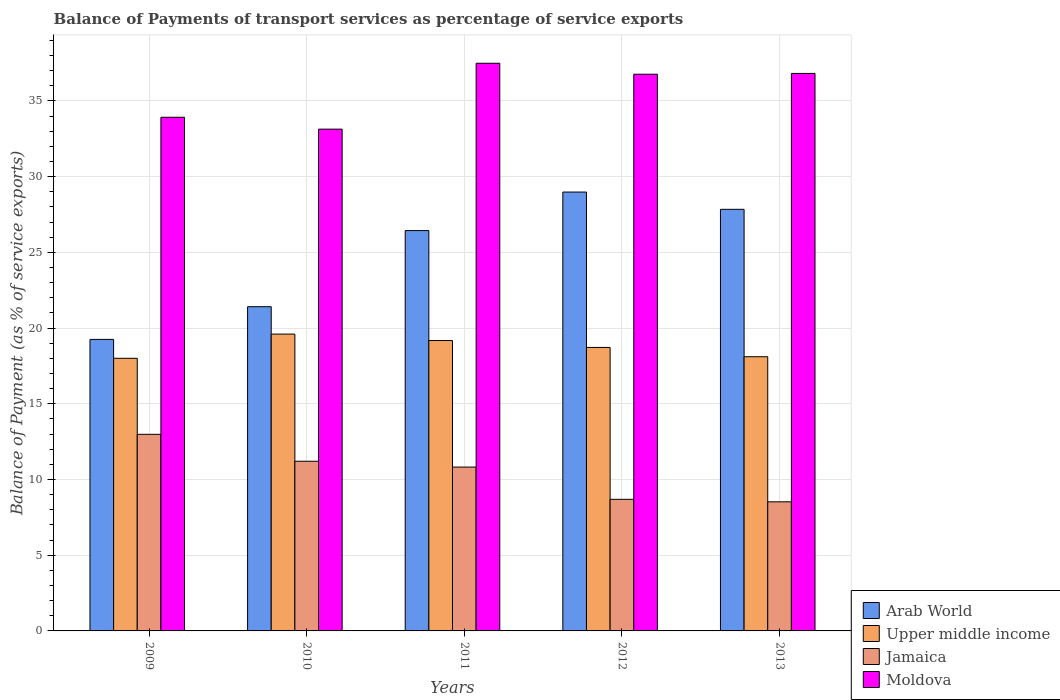How many different coloured bars are there?
Your answer should be very brief. 4. Are the number of bars on each tick of the X-axis equal?
Ensure brevity in your answer.  Yes. What is the label of the 1st group of bars from the left?
Your answer should be very brief. 2009. In how many cases, is the number of bars for a given year not equal to the number of legend labels?
Provide a succinct answer. 0. What is the balance of payments of transport services in Arab World in 2011?
Keep it short and to the point. 26.44. Across all years, what is the maximum balance of payments of transport services in Moldova?
Your response must be concise. 37.49. Across all years, what is the minimum balance of payments of transport services in Arab World?
Give a very brief answer. 19.25. In which year was the balance of payments of transport services in Moldova minimum?
Make the answer very short. 2010. What is the total balance of payments of transport services in Jamaica in the graph?
Make the answer very short. 52.23. What is the difference between the balance of payments of transport services in Jamaica in 2009 and that in 2013?
Give a very brief answer. 4.46. What is the difference between the balance of payments of transport services in Arab World in 2010 and the balance of payments of transport services in Upper middle income in 2009?
Your response must be concise. 3.41. What is the average balance of payments of transport services in Arab World per year?
Make the answer very short. 24.79. In the year 2011, what is the difference between the balance of payments of transport services in Upper middle income and balance of payments of transport services in Arab World?
Your answer should be very brief. -7.26. In how many years, is the balance of payments of transport services in Jamaica greater than 36 %?
Give a very brief answer. 0. What is the ratio of the balance of payments of transport services in Upper middle income in 2009 to that in 2010?
Offer a terse response. 0.92. Is the balance of payments of transport services in Jamaica in 2009 less than that in 2010?
Ensure brevity in your answer.  No. What is the difference between the highest and the second highest balance of payments of transport services in Upper middle income?
Offer a very short reply. 0.43. What is the difference between the highest and the lowest balance of payments of transport services in Moldova?
Ensure brevity in your answer.  4.35. In how many years, is the balance of payments of transport services in Jamaica greater than the average balance of payments of transport services in Jamaica taken over all years?
Your response must be concise. 3. What does the 4th bar from the left in 2012 represents?
Give a very brief answer. Moldova. What does the 1st bar from the right in 2011 represents?
Keep it short and to the point. Moldova. How many bars are there?
Your answer should be very brief. 20. What is the difference between two consecutive major ticks on the Y-axis?
Give a very brief answer. 5. Are the values on the major ticks of Y-axis written in scientific E-notation?
Provide a succinct answer. No. Does the graph contain any zero values?
Keep it short and to the point. No. Where does the legend appear in the graph?
Your response must be concise. Bottom right. How many legend labels are there?
Offer a terse response. 4. What is the title of the graph?
Your answer should be compact. Balance of Payments of transport services as percentage of service exports. What is the label or title of the Y-axis?
Offer a terse response. Balance of Payment (as % of service exports). What is the Balance of Payment (as % of service exports) in Arab World in 2009?
Ensure brevity in your answer.  19.25. What is the Balance of Payment (as % of service exports) in Upper middle income in 2009?
Provide a short and direct response. 18.01. What is the Balance of Payment (as % of service exports) in Jamaica in 2009?
Provide a succinct answer. 12.98. What is the Balance of Payment (as % of service exports) in Moldova in 2009?
Give a very brief answer. 33.93. What is the Balance of Payment (as % of service exports) of Arab World in 2010?
Ensure brevity in your answer.  21.41. What is the Balance of Payment (as % of service exports) of Upper middle income in 2010?
Give a very brief answer. 19.6. What is the Balance of Payment (as % of service exports) in Jamaica in 2010?
Your answer should be very brief. 11.21. What is the Balance of Payment (as % of service exports) of Moldova in 2010?
Ensure brevity in your answer.  33.14. What is the Balance of Payment (as % of service exports) in Arab World in 2011?
Offer a terse response. 26.44. What is the Balance of Payment (as % of service exports) in Upper middle income in 2011?
Your response must be concise. 19.18. What is the Balance of Payment (as % of service exports) in Jamaica in 2011?
Offer a very short reply. 10.82. What is the Balance of Payment (as % of service exports) of Moldova in 2011?
Provide a short and direct response. 37.49. What is the Balance of Payment (as % of service exports) in Arab World in 2012?
Your response must be concise. 28.99. What is the Balance of Payment (as % of service exports) in Upper middle income in 2012?
Offer a very short reply. 18.72. What is the Balance of Payment (as % of service exports) in Jamaica in 2012?
Offer a terse response. 8.69. What is the Balance of Payment (as % of service exports) in Moldova in 2012?
Keep it short and to the point. 36.77. What is the Balance of Payment (as % of service exports) of Arab World in 2013?
Keep it short and to the point. 27.85. What is the Balance of Payment (as % of service exports) of Upper middle income in 2013?
Ensure brevity in your answer.  18.11. What is the Balance of Payment (as % of service exports) of Jamaica in 2013?
Offer a terse response. 8.53. What is the Balance of Payment (as % of service exports) in Moldova in 2013?
Provide a succinct answer. 36.82. Across all years, what is the maximum Balance of Payment (as % of service exports) of Arab World?
Keep it short and to the point. 28.99. Across all years, what is the maximum Balance of Payment (as % of service exports) of Upper middle income?
Give a very brief answer. 19.6. Across all years, what is the maximum Balance of Payment (as % of service exports) in Jamaica?
Offer a very short reply. 12.98. Across all years, what is the maximum Balance of Payment (as % of service exports) of Moldova?
Your response must be concise. 37.49. Across all years, what is the minimum Balance of Payment (as % of service exports) of Arab World?
Offer a very short reply. 19.25. Across all years, what is the minimum Balance of Payment (as % of service exports) in Upper middle income?
Ensure brevity in your answer.  18.01. Across all years, what is the minimum Balance of Payment (as % of service exports) of Jamaica?
Give a very brief answer. 8.53. Across all years, what is the minimum Balance of Payment (as % of service exports) in Moldova?
Your answer should be compact. 33.14. What is the total Balance of Payment (as % of service exports) of Arab World in the graph?
Provide a short and direct response. 123.94. What is the total Balance of Payment (as % of service exports) in Upper middle income in the graph?
Make the answer very short. 93.62. What is the total Balance of Payment (as % of service exports) of Jamaica in the graph?
Offer a terse response. 52.23. What is the total Balance of Payment (as % of service exports) of Moldova in the graph?
Offer a very short reply. 178.15. What is the difference between the Balance of Payment (as % of service exports) in Arab World in 2009 and that in 2010?
Give a very brief answer. -2.16. What is the difference between the Balance of Payment (as % of service exports) of Upper middle income in 2009 and that in 2010?
Offer a terse response. -1.6. What is the difference between the Balance of Payment (as % of service exports) of Jamaica in 2009 and that in 2010?
Provide a short and direct response. 1.78. What is the difference between the Balance of Payment (as % of service exports) in Moldova in 2009 and that in 2010?
Provide a succinct answer. 0.78. What is the difference between the Balance of Payment (as % of service exports) of Arab World in 2009 and that in 2011?
Keep it short and to the point. -7.19. What is the difference between the Balance of Payment (as % of service exports) of Upper middle income in 2009 and that in 2011?
Offer a terse response. -1.17. What is the difference between the Balance of Payment (as % of service exports) in Jamaica in 2009 and that in 2011?
Give a very brief answer. 2.16. What is the difference between the Balance of Payment (as % of service exports) of Moldova in 2009 and that in 2011?
Provide a short and direct response. -3.57. What is the difference between the Balance of Payment (as % of service exports) of Arab World in 2009 and that in 2012?
Give a very brief answer. -9.73. What is the difference between the Balance of Payment (as % of service exports) of Upper middle income in 2009 and that in 2012?
Ensure brevity in your answer.  -0.72. What is the difference between the Balance of Payment (as % of service exports) in Jamaica in 2009 and that in 2012?
Make the answer very short. 4.29. What is the difference between the Balance of Payment (as % of service exports) in Moldova in 2009 and that in 2012?
Your answer should be very brief. -2.84. What is the difference between the Balance of Payment (as % of service exports) in Arab World in 2009 and that in 2013?
Offer a terse response. -8.59. What is the difference between the Balance of Payment (as % of service exports) in Upper middle income in 2009 and that in 2013?
Your answer should be compact. -0.1. What is the difference between the Balance of Payment (as % of service exports) in Jamaica in 2009 and that in 2013?
Provide a short and direct response. 4.46. What is the difference between the Balance of Payment (as % of service exports) of Moldova in 2009 and that in 2013?
Ensure brevity in your answer.  -2.9. What is the difference between the Balance of Payment (as % of service exports) of Arab World in 2010 and that in 2011?
Keep it short and to the point. -5.03. What is the difference between the Balance of Payment (as % of service exports) in Upper middle income in 2010 and that in 2011?
Provide a succinct answer. 0.43. What is the difference between the Balance of Payment (as % of service exports) in Jamaica in 2010 and that in 2011?
Provide a succinct answer. 0.39. What is the difference between the Balance of Payment (as % of service exports) of Moldova in 2010 and that in 2011?
Keep it short and to the point. -4.35. What is the difference between the Balance of Payment (as % of service exports) of Arab World in 2010 and that in 2012?
Ensure brevity in your answer.  -7.57. What is the difference between the Balance of Payment (as % of service exports) of Upper middle income in 2010 and that in 2012?
Keep it short and to the point. 0.88. What is the difference between the Balance of Payment (as % of service exports) of Jamaica in 2010 and that in 2012?
Offer a terse response. 2.52. What is the difference between the Balance of Payment (as % of service exports) of Moldova in 2010 and that in 2012?
Make the answer very short. -3.63. What is the difference between the Balance of Payment (as % of service exports) in Arab World in 2010 and that in 2013?
Offer a very short reply. -6.43. What is the difference between the Balance of Payment (as % of service exports) in Upper middle income in 2010 and that in 2013?
Your response must be concise. 1.49. What is the difference between the Balance of Payment (as % of service exports) in Jamaica in 2010 and that in 2013?
Provide a succinct answer. 2.68. What is the difference between the Balance of Payment (as % of service exports) of Moldova in 2010 and that in 2013?
Your answer should be very brief. -3.68. What is the difference between the Balance of Payment (as % of service exports) in Arab World in 2011 and that in 2012?
Give a very brief answer. -2.54. What is the difference between the Balance of Payment (as % of service exports) in Upper middle income in 2011 and that in 2012?
Give a very brief answer. 0.45. What is the difference between the Balance of Payment (as % of service exports) in Jamaica in 2011 and that in 2012?
Your answer should be compact. 2.13. What is the difference between the Balance of Payment (as % of service exports) in Moldova in 2011 and that in 2012?
Ensure brevity in your answer.  0.72. What is the difference between the Balance of Payment (as % of service exports) of Arab World in 2011 and that in 2013?
Keep it short and to the point. -1.4. What is the difference between the Balance of Payment (as % of service exports) of Upper middle income in 2011 and that in 2013?
Provide a short and direct response. 1.07. What is the difference between the Balance of Payment (as % of service exports) of Jamaica in 2011 and that in 2013?
Your response must be concise. 2.29. What is the difference between the Balance of Payment (as % of service exports) of Moldova in 2011 and that in 2013?
Your answer should be compact. 0.67. What is the difference between the Balance of Payment (as % of service exports) in Arab World in 2012 and that in 2013?
Keep it short and to the point. 1.14. What is the difference between the Balance of Payment (as % of service exports) of Upper middle income in 2012 and that in 2013?
Keep it short and to the point. 0.61. What is the difference between the Balance of Payment (as % of service exports) in Jamaica in 2012 and that in 2013?
Provide a succinct answer. 0.17. What is the difference between the Balance of Payment (as % of service exports) in Moldova in 2012 and that in 2013?
Ensure brevity in your answer.  -0.05. What is the difference between the Balance of Payment (as % of service exports) in Arab World in 2009 and the Balance of Payment (as % of service exports) in Upper middle income in 2010?
Offer a terse response. -0.35. What is the difference between the Balance of Payment (as % of service exports) in Arab World in 2009 and the Balance of Payment (as % of service exports) in Jamaica in 2010?
Offer a terse response. 8.05. What is the difference between the Balance of Payment (as % of service exports) in Arab World in 2009 and the Balance of Payment (as % of service exports) in Moldova in 2010?
Keep it short and to the point. -13.89. What is the difference between the Balance of Payment (as % of service exports) in Upper middle income in 2009 and the Balance of Payment (as % of service exports) in Jamaica in 2010?
Offer a terse response. 6.8. What is the difference between the Balance of Payment (as % of service exports) in Upper middle income in 2009 and the Balance of Payment (as % of service exports) in Moldova in 2010?
Make the answer very short. -15.13. What is the difference between the Balance of Payment (as % of service exports) of Jamaica in 2009 and the Balance of Payment (as % of service exports) of Moldova in 2010?
Keep it short and to the point. -20.16. What is the difference between the Balance of Payment (as % of service exports) of Arab World in 2009 and the Balance of Payment (as % of service exports) of Upper middle income in 2011?
Make the answer very short. 0.08. What is the difference between the Balance of Payment (as % of service exports) in Arab World in 2009 and the Balance of Payment (as % of service exports) in Jamaica in 2011?
Make the answer very short. 8.43. What is the difference between the Balance of Payment (as % of service exports) of Arab World in 2009 and the Balance of Payment (as % of service exports) of Moldova in 2011?
Ensure brevity in your answer.  -18.24. What is the difference between the Balance of Payment (as % of service exports) of Upper middle income in 2009 and the Balance of Payment (as % of service exports) of Jamaica in 2011?
Keep it short and to the point. 7.18. What is the difference between the Balance of Payment (as % of service exports) in Upper middle income in 2009 and the Balance of Payment (as % of service exports) in Moldova in 2011?
Your response must be concise. -19.49. What is the difference between the Balance of Payment (as % of service exports) in Jamaica in 2009 and the Balance of Payment (as % of service exports) in Moldova in 2011?
Give a very brief answer. -24.51. What is the difference between the Balance of Payment (as % of service exports) of Arab World in 2009 and the Balance of Payment (as % of service exports) of Upper middle income in 2012?
Offer a terse response. 0.53. What is the difference between the Balance of Payment (as % of service exports) in Arab World in 2009 and the Balance of Payment (as % of service exports) in Jamaica in 2012?
Keep it short and to the point. 10.56. What is the difference between the Balance of Payment (as % of service exports) in Arab World in 2009 and the Balance of Payment (as % of service exports) in Moldova in 2012?
Provide a short and direct response. -17.51. What is the difference between the Balance of Payment (as % of service exports) of Upper middle income in 2009 and the Balance of Payment (as % of service exports) of Jamaica in 2012?
Your answer should be compact. 9.31. What is the difference between the Balance of Payment (as % of service exports) of Upper middle income in 2009 and the Balance of Payment (as % of service exports) of Moldova in 2012?
Your answer should be compact. -18.76. What is the difference between the Balance of Payment (as % of service exports) in Jamaica in 2009 and the Balance of Payment (as % of service exports) in Moldova in 2012?
Your answer should be compact. -23.78. What is the difference between the Balance of Payment (as % of service exports) in Arab World in 2009 and the Balance of Payment (as % of service exports) in Upper middle income in 2013?
Your answer should be compact. 1.14. What is the difference between the Balance of Payment (as % of service exports) in Arab World in 2009 and the Balance of Payment (as % of service exports) in Jamaica in 2013?
Your response must be concise. 10.73. What is the difference between the Balance of Payment (as % of service exports) of Arab World in 2009 and the Balance of Payment (as % of service exports) of Moldova in 2013?
Your answer should be very brief. -17.57. What is the difference between the Balance of Payment (as % of service exports) in Upper middle income in 2009 and the Balance of Payment (as % of service exports) in Jamaica in 2013?
Ensure brevity in your answer.  9.48. What is the difference between the Balance of Payment (as % of service exports) in Upper middle income in 2009 and the Balance of Payment (as % of service exports) in Moldova in 2013?
Your answer should be compact. -18.81. What is the difference between the Balance of Payment (as % of service exports) of Jamaica in 2009 and the Balance of Payment (as % of service exports) of Moldova in 2013?
Provide a short and direct response. -23.84. What is the difference between the Balance of Payment (as % of service exports) of Arab World in 2010 and the Balance of Payment (as % of service exports) of Upper middle income in 2011?
Offer a terse response. 2.24. What is the difference between the Balance of Payment (as % of service exports) of Arab World in 2010 and the Balance of Payment (as % of service exports) of Jamaica in 2011?
Your answer should be very brief. 10.59. What is the difference between the Balance of Payment (as % of service exports) of Arab World in 2010 and the Balance of Payment (as % of service exports) of Moldova in 2011?
Keep it short and to the point. -16.08. What is the difference between the Balance of Payment (as % of service exports) of Upper middle income in 2010 and the Balance of Payment (as % of service exports) of Jamaica in 2011?
Offer a very short reply. 8.78. What is the difference between the Balance of Payment (as % of service exports) in Upper middle income in 2010 and the Balance of Payment (as % of service exports) in Moldova in 2011?
Ensure brevity in your answer.  -17.89. What is the difference between the Balance of Payment (as % of service exports) in Jamaica in 2010 and the Balance of Payment (as % of service exports) in Moldova in 2011?
Your answer should be compact. -26.29. What is the difference between the Balance of Payment (as % of service exports) of Arab World in 2010 and the Balance of Payment (as % of service exports) of Upper middle income in 2012?
Offer a terse response. 2.69. What is the difference between the Balance of Payment (as % of service exports) in Arab World in 2010 and the Balance of Payment (as % of service exports) in Jamaica in 2012?
Offer a very short reply. 12.72. What is the difference between the Balance of Payment (as % of service exports) of Arab World in 2010 and the Balance of Payment (as % of service exports) of Moldova in 2012?
Provide a short and direct response. -15.35. What is the difference between the Balance of Payment (as % of service exports) in Upper middle income in 2010 and the Balance of Payment (as % of service exports) in Jamaica in 2012?
Provide a short and direct response. 10.91. What is the difference between the Balance of Payment (as % of service exports) in Upper middle income in 2010 and the Balance of Payment (as % of service exports) in Moldova in 2012?
Offer a terse response. -17.16. What is the difference between the Balance of Payment (as % of service exports) of Jamaica in 2010 and the Balance of Payment (as % of service exports) of Moldova in 2012?
Provide a succinct answer. -25.56. What is the difference between the Balance of Payment (as % of service exports) in Arab World in 2010 and the Balance of Payment (as % of service exports) in Upper middle income in 2013?
Your answer should be compact. 3.3. What is the difference between the Balance of Payment (as % of service exports) in Arab World in 2010 and the Balance of Payment (as % of service exports) in Jamaica in 2013?
Make the answer very short. 12.89. What is the difference between the Balance of Payment (as % of service exports) of Arab World in 2010 and the Balance of Payment (as % of service exports) of Moldova in 2013?
Ensure brevity in your answer.  -15.41. What is the difference between the Balance of Payment (as % of service exports) in Upper middle income in 2010 and the Balance of Payment (as % of service exports) in Jamaica in 2013?
Ensure brevity in your answer.  11.08. What is the difference between the Balance of Payment (as % of service exports) of Upper middle income in 2010 and the Balance of Payment (as % of service exports) of Moldova in 2013?
Provide a short and direct response. -17.22. What is the difference between the Balance of Payment (as % of service exports) of Jamaica in 2010 and the Balance of Payment (as % of service exports) of Moldova in 2013?
Offer a terse response. -25.61. What is the difference between the Balance of Payment (as % of service exports) in Arab World in 2011 and the Balance of Payment (as % of service exports) in Upper middle income in 2012?
Keep it short and to the point. 7.72. What is the difference between the Balance of Payment (as % of service exports) in Arab World in 2011 and the Balance of Payment (as % of service exports) in Jamaica in 2012?
Give a very brief answer. 17.75. What is the difference between the Balance of Payment (as % of service exports) in Arab World in 2011 and the Balance of Payment (as % of service exports) in Moldova in 2012?
Give a very brief answer. -10.33. What is the difference between the Balance of Payment (as % of service exports) of Upper middle income in 2011 and the Balance of Payment (as % of service exports) of Jamaica in 2012?
Ensure brevity in your answer.  10.49. What is the difference between the Balance of Payment (as % of service exports) in Upper middle income in 2011 and the Balance of Payment (as % of service exports) in Moldova in 2012?
Provide a short and direct response. -17.59. What is the difference between the Balance of Payment (as % of service exports) in Jamaica in 2011 and the Balance of Payment (as % of service exports) in Moldova in 2012?
Offer a very short reply. -25.95. What is the difference between the Balance of Payment (as % of service exports) of Arab World in 2011 and the Balance of Payment (as % of service exports) of Upper middle income in 2013?
Provide a short and direct response. 8.33. What is the difference between the Balance of Payment (as % of service exports) of Arab World in 2011 and the Balance of Payment (as % of service exports) of Jamaica in 2013?
Your answer should be very brief. 17.91. What is the difference between the Balance of Payment (as % of service exports) of Arab World in 2011 and the Balance of Payment (as % of service exports) of Moldova in 2013?
Offer a very short reply. -10.38. What is the difference between the Balance of Payment (as % of service exports) in Upper middle income in 2011 and the Balance of Payment (as % of service exports) in Jamaica in 2013?
Your response must be concise. 10.65. What is the difference between the Balance of Payment (as % of service exports) of Upper middle income in 2011 and the Balance of Payment (as % of service exports) of Moldova in 2013?
Offer a terse response. -17.64. What is the difference between the Balance of Payment (as % of service exports) of Jamaica in 2011 and the Balance of Payment (as % of service exports) of Moldova in 2013?
Give a very brief answer. -26. What is the difference between the Balance of Payment (as % of service exports) in Arab World in 2012 and the Balance of Payment (as % of service exports) in Upper middle income in 2013?
Your response must be concise. 10.88. What is the difference between the Balance of Payment (as % of service exports) of Arab World in 2012 and the Balance of Payment (as % of service exports) of Jamaica in 2013?
Offer a very short reply. 20.46. What is the difference between the Balance of Payment (as % of service exports) in Arab World in 2012 and the Balance of Payment (as % of service exports) in Moldova in 2013?
Your answer should be very brief. -7.84. What is the difference between the Balance of Payment (as % of service exports) in Upper middle income in 2012 and the Balance of Payment (as % of service exports) in Jamaica in 2013?
Provide a short and direct response. 10.2. What is the difference between the Balance of Payment (as % of service exports) in Upper middle income in 2012 and the Balance of Payment (as % of service exports) in Moldova in 2013?
Offer a terse response. -18.1. What is the difference between the Balance of Payment (as % of service exports) of Jamaica in 2012 and the Balance of Payment (as % of service exports) of Moldova in 2013?
Ensure brevity in your answer.  -28.13. What is the average Balance of Payment (as % of service exports) of Arab World per year?
Your response must be concise. 24.79. What is the average Balance of Payment (as % of service exports) of Upper middle income per year?
Your answer should be compact. 18.72. What is the average Balance of Payment (as % of service exports) of Jamaica per year?
Your answer should be compact. 10.45. What is the average Balance of Payment (as % of service exports) in Moldova per year?
Your response must be concise. 35.63. In the year 2009, what is the difference between the Balance of Payment (as % of service exports) in Arab World and Balance of Payment (as % of service exports) in Upper middle income?
Offer a very short reply. 1.25. In the year 2009, what is the difference between the Balance of Payment (as % of service exports) of Arab World and Balance of Payment (as % of service exports) of Jamaica?
Keep it short and to the point. 6.27. In the year 2009, what is the difference between the Balance of Payment (as % of service exports) of Arab World and Balance of Payment (as % of service exports) of Moldova?
Make the answer very short. -14.67. In the year 2009, what is the difference between the Balance of Payment (as % of service exports) in Upper middle income and Balance of Payment (as % of service exports) in Jamaica?
Offer a terse response. 5.02. In the year 2009, what is the difference between the Balance of Payment (as % of service exports) of Upper middle income and Balance of Payment (as % of service exports) of Moldova?
Keep it short and to the point. -15.92. In the year 2009, what is the difference between the Balance of Payment (as % of service exports) in Jamaica and Balance of Payment (as % of service exports) in Moldova?
Your response must be concise. -20.94. In the year 2010, what is the difference between the Balance of Payment (as % of service exports) in Arab World and Balance of Payment (as % of service exports) in Upper middle income?
Offer a very short reply. 1.81. In the year 2010, what is the difference between the Balance of Payment (as % of service exports) of Arab World and Balance of Payment (as % of service exports) of Jamaica?
Provide a succinct answer. 10.21. In the year 2010, what is the difference between the Balance of Payment (as % of service exports) in Arab World and Balance of Payment (as % of service exports) in Moldova?
Give a very brief answer. -11.73. In the year 2010, what is the difference between the Balance of Payment (as % of service exports) in Upper middle income and Balance of Payment (as % of service exports) in Jamaica?
Give a very brief answer. 8.4. In the year 2010, what is the difference between the Balance of Payment (as % of service exports) of Upper middle income and Balance of Payment (as % of service exports) of Moldova?
Provide a succinct answer. -13.54. In the year 2010, what is the difference between the Balance of Payment (as % of service exports) in Jamaica and Balance of Payment (as % of service exports) in Moldova?
Offer a very short reply. -21.93. In the year 2011, what is the difference between the Balance of Payment (as % of service exports) in Arab World and Balance of Payment (as % of service exports) in Upper middle income?
Give a very brief answer. 7.26. In the year 2011, what is the difference between the Balance of Payment (as % of service exports) of Arab World and Balance of Payment (as % of service exports) of Jamaica?
Your response must be concise. 15.62. In the year 2011, what is the difference between the Balance of Payment (as % of service exports) of Arab World and Balance of Payment (as % of service exports) of Moldova?
Provide a short and direct response. -11.05. In the year 2011, what is the difference between the Balance of Payment (as % of service exports) in Upper middle income and Balance of Payment (as % of service exports) in Jamaica?
Ensure brevity in your answer.  8.36. In the year 2011, what is the difference between the Balance of Payment (as % of service exports) in Upper middle income and Balance of Payment (as % of service exports) in Moldova?
Ensure brevity in your answer.  -18.31. In the year 2011, what is the difference between the Balance of Payment (as % of service exports) of Jamaica and Balance of Payment (as % of service exports) of Moldova?
Your answer should be very brief. -26.67. In the year 2012, what is the difference between the Balance of Payment (as % of service exports) of Arab World and Balance of Payment (as % of service exports) of Upper middle income?
Give a very brief answer. 10.26. In the year 2012, what is the difference between the Balance of Payment (as % of service exports) in Arab World and Balance of Payment (as % of service exports) in Jamaica?
Offer a terse response. 20.29. In the year 2012, what is the difference between the Balance of Payment (as % of service exports) of Arab World and Balance of Payment (as % of service exports) of Moldova?
Your answer should be compact. -7.78. In the year 2012, what is the difference between the Balance of Payment (as % of service exports) of Upper middle income and Balance of Payment (as % of service exports) of Jamaica?
Provide a short and direct response. 10.03. In the year 2012, what is the difference between the Balance of Payment (as % of service exports) of Upper middle income and Balance of Payment (as % of service exports) of Moldova?
Your answer should be very brief. -18.04. In the year 2012, what is the difference between the Balance of Payment (as % of service exports) of Jamaica and Balance of Payment (as % of service exports) of Moldova?
Keep it short and to the point. -28.08. In the year 2013, what is the difference between the Balance of Payment (as % of service exports) in Arab World and Balance of Payment (as % of service exports) in Upper middle income?
Offer a terse response. 9.74. In the year 2013, what is the difference between the Balance of Payment (as % of service exports) in Arab World and Balance of Payment (as % of service exports) in Jamaica?
Your answer should be very brief. 19.32. In the year 2013, what is the difference between the Balance of Payment (as % of service exports) of Arab World and Balance of Payment (as % of service exports) of Moldova?
Provide a succinct answer. -8.98. In the year 2013, what is the difference between the Balance of Payment (as % of service exports) of Upper middle income and Balance of Payment (as % of service exports) of Jamaica?
Give a very brief answer. 9.58. In the year 2013, what is the difference between the Balance of Payment (as % of service exports) in Upper middle income and Balance of Payment (as % of service exports) in Moldova?
Offer a very short reply. -18.71. In the year 2013, what is the difference between the Balance of Payment (as % of service exports) of Jamaica and Balance of Payment (as % of service exports) of Moldova?
Make the answer very short. -28.29. What is the ratio of the Balance of Payment (as % of service exports) in Arab World in 2009 to that in 2010?
Keep it short and to the point. 0.9. What is the ratio of the Balance of Payment (as % of service exports) of Upper middle income in 2009 to that in 2010?
Make the answer very short. 0.92. What is the ratio of the Balance of Payment (as % of service exports) in Jamaica in 2009 to that in 2010?
Offer a terse response. 1.16. What is the ratio of the Balance of Payment (as % of service exports) in Moldova in 2009 to that in 2010?
Your response must be concise. 1.02. What is the ratio of the Balance of Payment (as % of service exports) in Arab World in 2009 to that in 2011?
Make the answer very short. 0.73. What is the ratio of the Balance of Payment (as % of service exports) of Upper middle income in 2009 to that in 2011?
Provide a short and direct response. 0.94. What is the ratio of the Balance of Payment (as % of service exports) in Jamaica in 2009 to that in 2011?
Provide a short and direct response. 1.2. What is the ratio of the Balance of Payment (as % of service exports) of Moldova in 2009 to that in 2011?
Provide a short and direct response. 0.9. What is the ratio of the Balance of Payment (as % of service exports) in Arab World in 2009 to that in 2012?
Your answer should be very brief. 0.66. What is the ratio of the Balance of Payment (as % of service exports) of Upper middle income in 2009 to that in 2012?
Ensure brevity in your answer.  0.96. What is the ratio of the Balance of Payment (as % of service exports) in Jamaica in 2009 to that in 2012?
Make the answer very short. 1.49. What is the ratio of the Balance of Payment (as % of service exports) of Moldova in 2009 to that in 2012?
Offer a very short reply. 0.92. What is the ratio of the Balance of Payment (as % of service exports) of Arab World in 2009 to that in 2013?
Ensure brevity in your answer.  0.69. What is the ratio of the Balance of Payment (as % of service exports) of Jamaica in 2009 to that in 2013?
Make the answer very short. 1.52. What is the ratio of the Balance of Payment (as % of service exports) of Moldova in 2009 to that in 2013?
Make the answer very short. 0.92. What is the ratio of the Balance of Payment (as % of service exports) of Arab World in 2010 to that in 2011?
Your answer should be compact. 0.81. What is the ratio of the Balance of Payment (as % of service exports) of Upper middle income in 2010 to that in 2011?
Offer a terse response. 1.02. What is the ratio of the Balance of Payment (as % of service exports) in Jamaica in 2010 to that in 2011?
Ensure brevity in your answer.  1.04. What is the ratio of the Balance of Payment (as % of service exports) in Moldova in 2010 to that in 2011?
Ensure brevity in your answer.  0.88. What is the ratio of the Balance of Payment (as % of service exports) in Arab World in 2010 to that in 2012?
Your answer should be compact. 0.74. What is the ratio of the Balance of Payment (as % of service exports) in Upper middle income in 2010 to that in 2012?
Provide a short and direct response. 1.05. What is the ratio of the Balance of Payment (as % of service exports) of Jamaica in 2010 to that in 2012?
Your response must be concise. 1.29. What is the ratio of the Balance of Payment (as % of service exports) in Moldova in 2010 to that in 2012?
Your answer should be very brief. 0.9. What is the ratio of the Balance of Payment (as % of service exports) of Arab World in 2010 to that in 2013?
Your answer should be very brief. 0.77. What is the ratio of the Balance of Payment (as % of service exports) in Upper middle income in 2010 to that in 2013?
Offer a very short reply. 1.08. What is the ratio of the Balance of Payment (as % of service exports) of Jamaica in 2010 to that in 2013?
Offer a very short reply. 1.31. What is the ratio of the Balance of Payment (as % of service exports) of Moldova in 2010 to that in 2013?
Keep it short and to the point. 0.9. What is the ratio of the Balance of Payment (as % of service exports) in Arab World in 2011 to that in 2012?
Your response must be concise. 0.91. What is the ratio of the Balance of Payment (as % of service exports) in Upper middle income in 2011 to that in 2012?
Offer a terse response. 1.02. What is the ratio of the Balance of Payment (as % of service exports) of Jamaica in 2011 to that in 2012?
Ensure brevity in your answer.  1.25. What is the ratio of the Balance of Payment (as % of service exports) in Moldova in 2011 to that in 2012?
Your answer should be very brief. 1.02. What is the ratio of the Balance of Payment (as % of service exports) in Arab World in 2011 to that in 2013?
Offer a terse response. 0.95. What is the ratio of the Balance of Payment (as % of service exports) in Upper middle income in 2011 to that in 2013?
Provide a succinct answer. 1.06. What is the ratio of the Balance of Payment (as % of service exports) of Jamaica in 2011 to that in 2013?
Ensure brevity in your answer.  1.27. What is the ratio of the Balance of Payment (as % of service exports) of Moldova in 2011 to that in 2013?
Your response must be concise. 1.02. What is the ratio of the Balance of Payment (as % of service exports) of Arab World in 2012 to that in 2013?
Give a very brief answer. 1.04. What is the ratio of the Balance of Payment (as % of service exports) of Upper middle income in 2012 to that in 2013?
Ensure brevity in your answer.  1.03. What is the ratio of the Balance of Payment (as % of service exports) of Jamaica in 2012 to that in 2013?
Your answer should be very brief. 1.02. What is the difference between the highest and the second highest Balance of Payment (as % of service exports) of Arab World?
Provide a succinct answer. 1.14. What is the difference between the highest and the second highest Balance of Payment (as % of service exports) in Upper middle income?
Keep it short and to the point. 0.43. What is the difference between the highest and the second highest Balance of Payment (as % of service exports) of Jamaica?
Give a very brief answer. 1.78. What is the difference between the highest and the second highest Balance of Payment (as % of service exports) of Moldova?
Give a very brief answer. 0.67. What is the difference between the highest and the lowest Balance of Payment (as % of service exports) of Arab World?
Offer a terse response. 9.73. What is the difference between the highest and the lowest Balance of Payment (as % of service exports) in Upper middle income?
Your response must be concise. 1.6. What is the difference between the highest and the lowest Balance of Payment (as % of service exports) in Jamaica?
Offer a very short reply. 4.46. What is the difference between the highest and the lowest Balance of Payment (as % of service exports) in Moldova?
Provide a short and direct response. 4.35. 